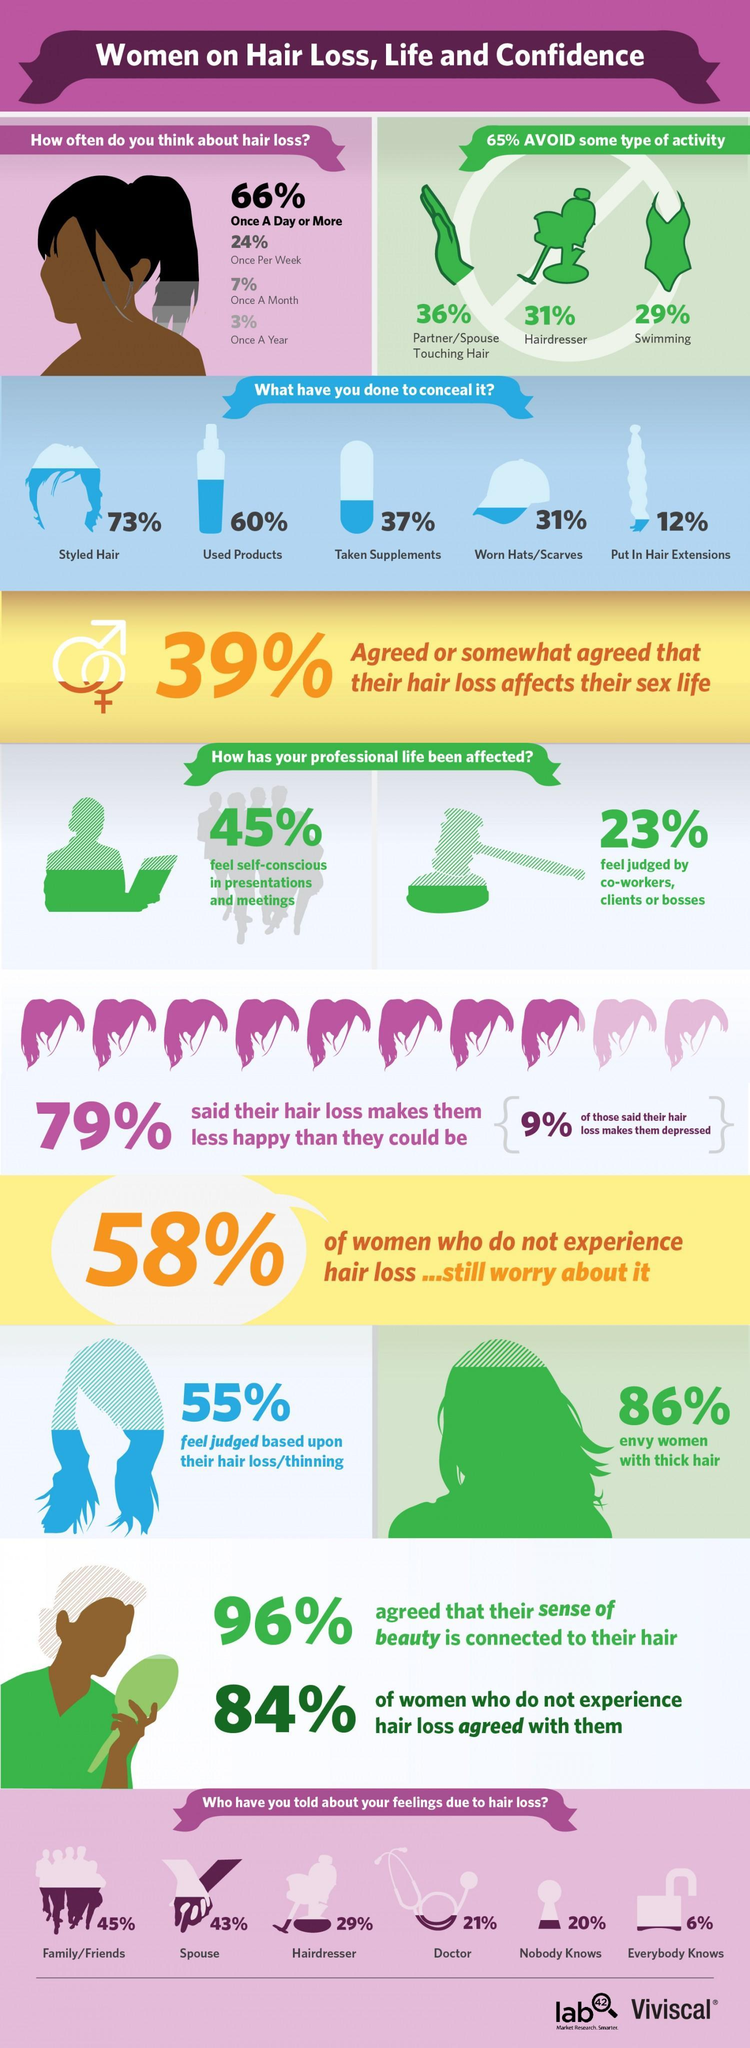What percentage of people avoid hairdressers and swimming, taken together?
Answer the question with a short phrase. 60% What percentage of people think about hair loss once a month and once a year, taken together? 10% What percentage of people tell their feelings due to hair loss to family and hairdresser, taken together? 74% What percentage of people are not jealous of women with thick hair? 14% What percentage of people avoid partner touching hair and swimming, taken together? 65% What percentage of women are not depressed with their hair loss? 91% What percentage of people tell their feelings due to hair loss to doctors and spouse, taken together? 64% What percentage of people worn hats and used products together to conceal the hair fall? 91% What percentage of people styled hair and taken supplements together to conceal the hair fall? 110% What percentage of people think about hair loss once a day and once per week, taken together? 90% What percentage of people not feared being judged by co-workers, clients, or bosses? 77% 